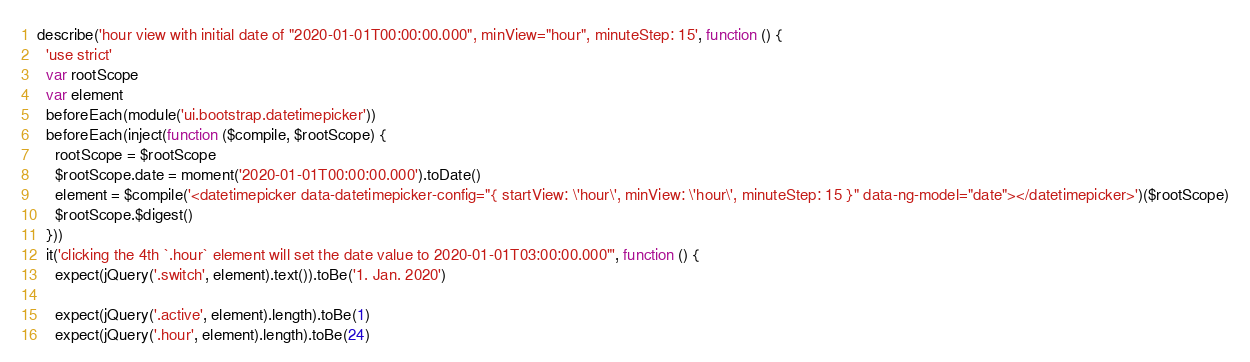<code> <loc_0><loc_0><loc_500><loc_500><_JavaScript_>
describe('hour view with initial date of "2020-01-01T00:00:00.000", minView="hour", minuteStep: 15', function () {
  'use strict'
  var rootScope
  var element
  beforeEach(module('ui.bootstrap.datetimepicker'))
  beforeEach(inject(function ($compile, $rootScope) {
    rootScope = $rootScope
    $rootScope.date = moment('2020-01-01T00:00:00.000').toDate()
    element = $compile('<datetimepicker data-datetimepicker-config="{ startView: \'hour\', minView: \'hour\', minuteStep: 15 }" data-ng-model="date"></datetimepicker>')($rootScope)
    $rootScope.$digest()
  }))
  it('clicking the 4th `.hour` element will set the date value to 2020-01-01T03:00:00.000"', function () {
    expect(jQuery('.switch', element).text()).toBe('1. Jan. 2020')

    expect(jQuery('.active', element).length).toBe(1)
    expect(jQuery('.hour', element).length).toBe(24)
</code> 